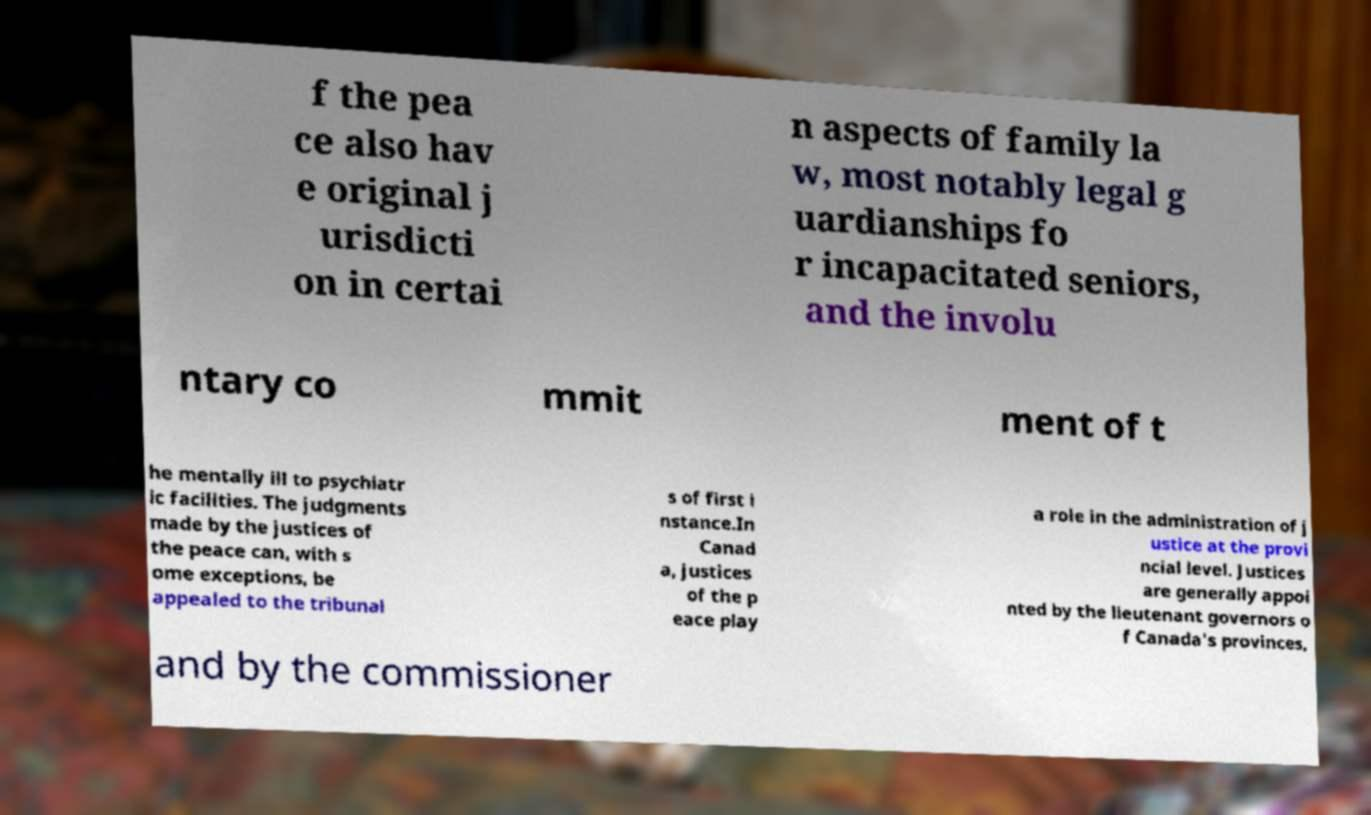There's text embedded in this image that I need extracted. Can you transcribe it verbatim? f the pea ce also hav e original j urisdicti on in certai n aspects of family la w, most notably legal g uardianships fo r incapacitated seniors, and the involu ntary co mmit ment of t he mentally ill to psychiatr ic facilities. The judgments made by the justices of the peace can, with s ome exceptions, be appealed to the tribunal s of first i nstance.In Canad a, justices of the p eace play a role in the administration of j ustice at the provi ncial level. Justices are generally appoi nted by the lieutenant governors o f Canada's provinces, and by the commissioner 